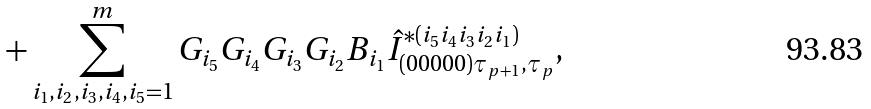<formula> <loc_0><loc_0><loc_500><loc_500>+ \sum _ { i _ { 1 } , i _ { 2 } , i _ { 3 } , i _ { 4 } , i _ { 5 } = 1 } ^ { m } G _ { i _ { 5 } } G _ { i _ { 4 } } G _ { i _ { 3 } } G _ { i _ { 2 } } B _ { i _ { 1 } } \hat { I } _ { ( 0 0 0 0 0 ) \tau _ { p + 1 } , \tau _ { p } } ^ { * ( i _ { 5 } i _ { 4 } i _ { 3 } i _ { 2 } i _ { 1 } ) } ,</formula> 